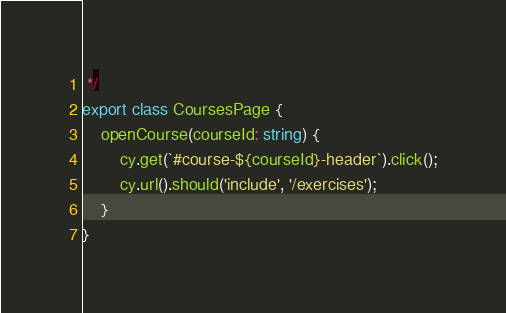Convert code to text. <code><loc_0><loc_0><loc_500><loc_500><_TypeScript_> */
export class CoursesPage {
    openCourse(courseId: string) {
        cy.get(`#course-${courseId}-header`).click();
        cy.url().should('include', '/exercises');
    }
}
</code> 